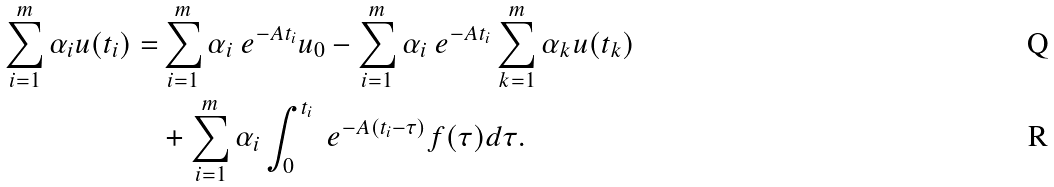<formula> <loc_0><loc_0><loc_500><loc_500>\sum _ { i = 1 } ^ { m } \alpha _ { i } u ( t _ { i } ) = & \sum _ { i = 1 } ^ { m } \alpha _ { i } \ e ^ { - A t _ { i } } u _ { 0 } - \sum _ { i = 1 } ^ { m } \alpha _ { i } \ e ^ { - A t _ { i } } \sum _ { k = 1 } ^ { m } \alpha _ { k } u ( t _ { k } ) \\ & + \sum _ { i = 1 } ^ { m } \alpha _ { i } \int _ { 0 } ^ { t _ { i } } \ e ^ { - A ( t _ { i } - \tau ) } f ( \tau ) d \tau .</formula> 